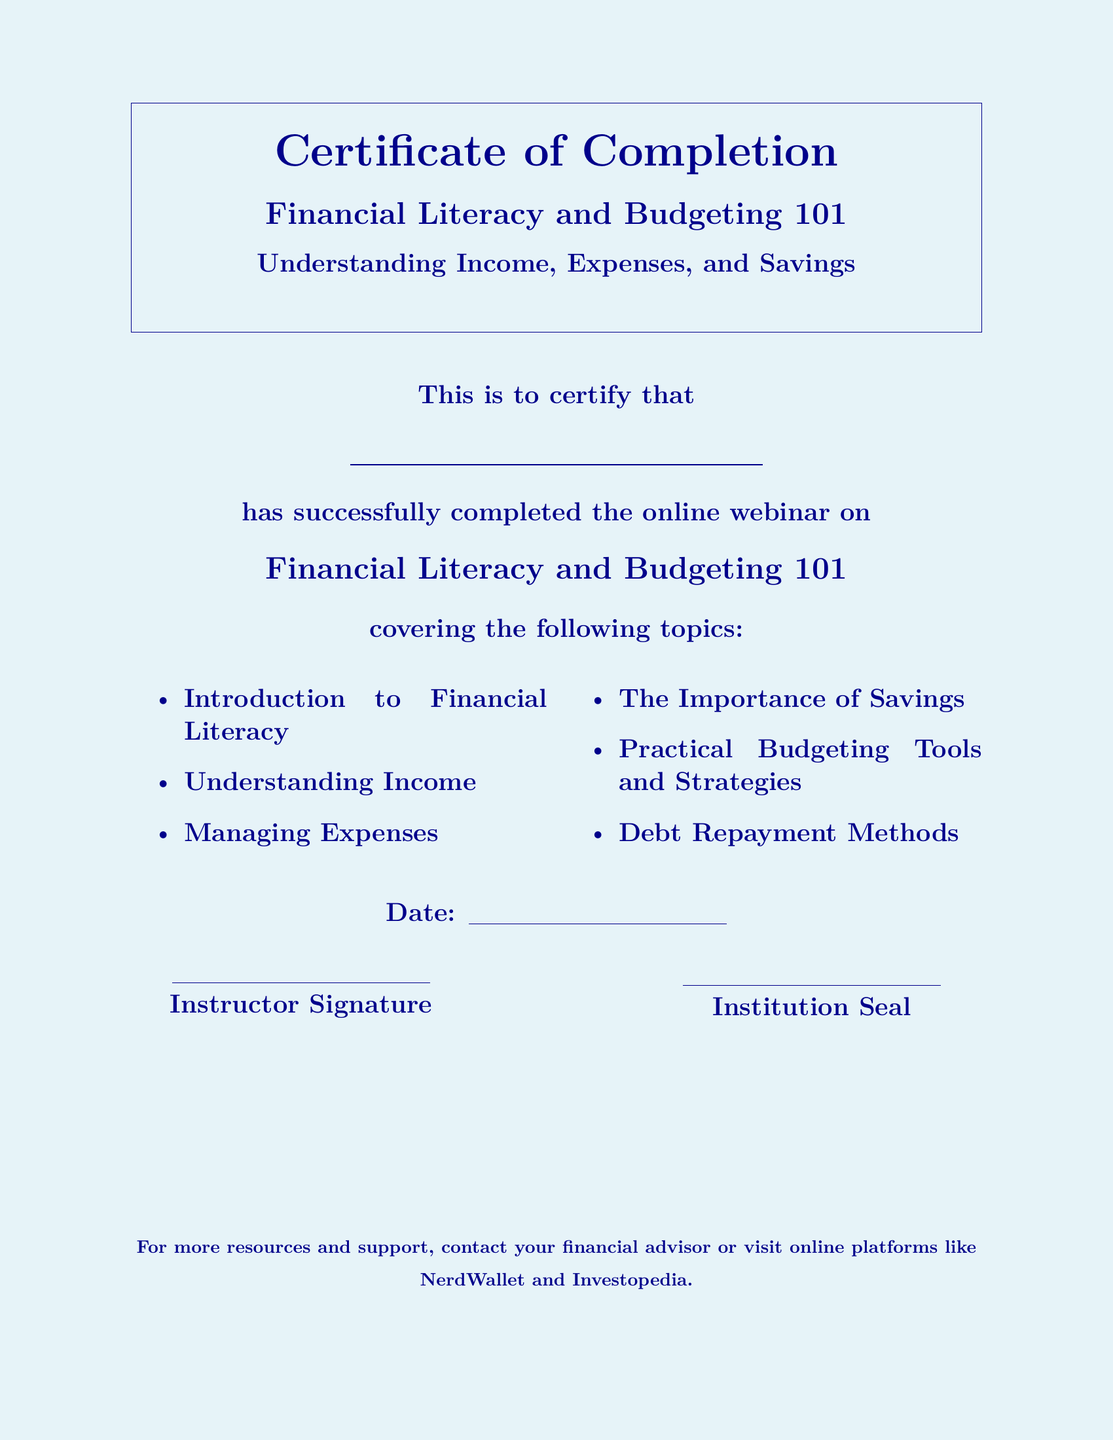What is the title of the webinar? The title of the webinar is listed in the document under the main heading.
Answer: Financial Literacy and Budgeting 101 Who has successfully completed the course? The participant's name is to be filled in the designated area in the document.
Answer: \underline{\hspace{8cm}} What is one of the topics covered in the webinar? The document lists several topics covered in the course.
Answer: Understanding Income Which budgeting tool or strategy is mentioned in the certificate? The topics covered include practical budgeting tools and strategies as part of the course.
Answer: Practical Budgeting Tools and Strategies What is the date format indicated in the document? The date is mentioned in a fillable space indicating it should be filled in, typically reflecting a date.
Answer: \underline{\hspace{5cm}} What is required for the instructor's confirmation? The instructor's confirmation is represented by a signature on the document.
Answer: Instructor Signature What is mentioned for further resources and support? The document encourages contacting a financial advisor or visiting specific online platforms for more support.
Answer: NerdWallet and Investopedia What type of document is this? The structure and content indicate it is an award given for completion of a course.
Answer: Certificate of Completion 